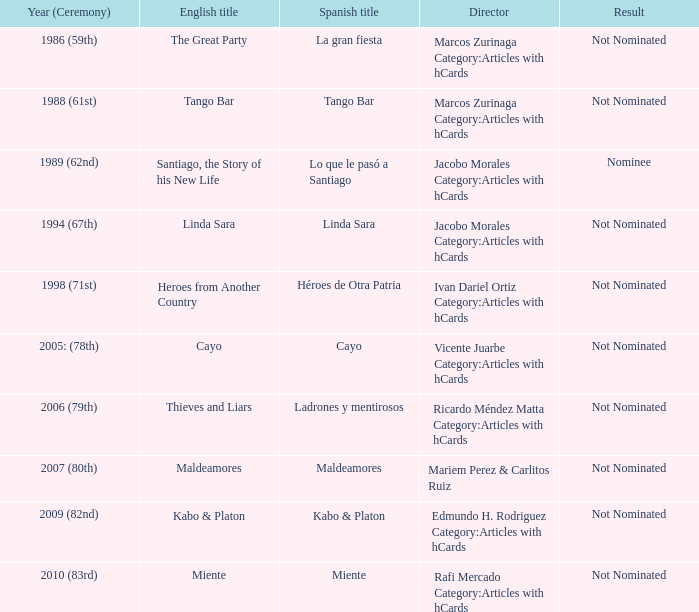Who was the filmmaker for tango bar? Marcos Zurinaga Category:Articles with hCards. 